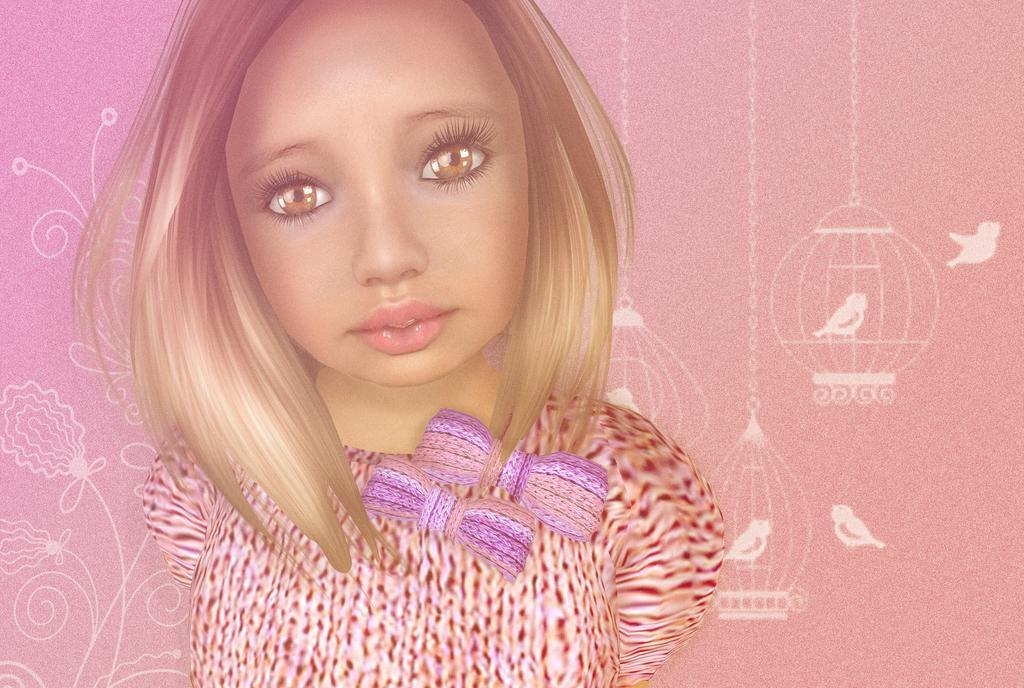Can you describe this image briefly? In this picture I can see a girl in the middle, in the background there are paintings on the wall, it is an animation. 